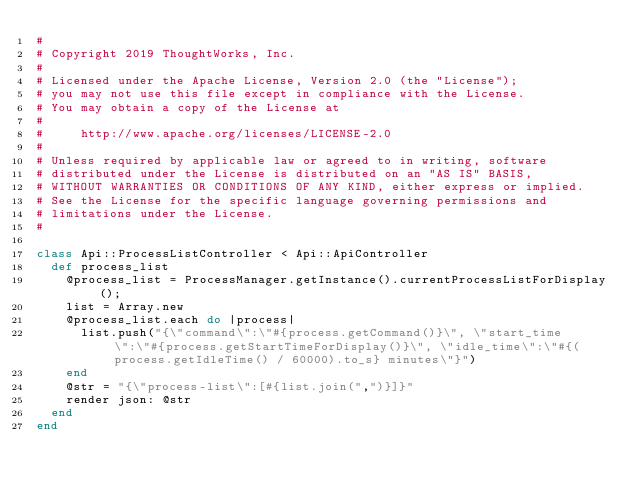Convert code to text. <code><loc_0><loc_0><loc_500><loc_500><_Ruby_>#
# Copyright 2019 ThoughtWorks, Inc.
#
# Licensed under the Apache License, Version 2.0 (the "License");
# you may not use this file except in compliance with the License.
# You may obtain a copy of the License at
#
#     http://www.apache.org/licenses/LICENSE-2.0
#
# Unless required by applicable law or agreed to in writing, software
# distributed under the License is distributed on an "AS IS" BASIS,
# WITHOUT WARRANTIES OR CONDITIONS OF ANY KIND, either express or implied.
# See the License for the specific language governing permissions and
# limitations under the License.
#

class Api::ProcessListController < Api::ApiController
  def process_list
    @process_list = ProcessManager.getInstance().currentProcessListForDisplay();
    list = Array.new
    @process_list.each do |process|
      list.push("{\"command\":\"#{process.getCommand()}\", \"start_time\":\"#{process.getStartTimeForDisplay()}\", \"idle_time\":\"#{(process.getIdleTime() / 60000).to_s} minutes\"}")
    end
    @str = "{\"process-list\":[#{list.join(",")}]}"
    render json: @str
  end
end</code> 